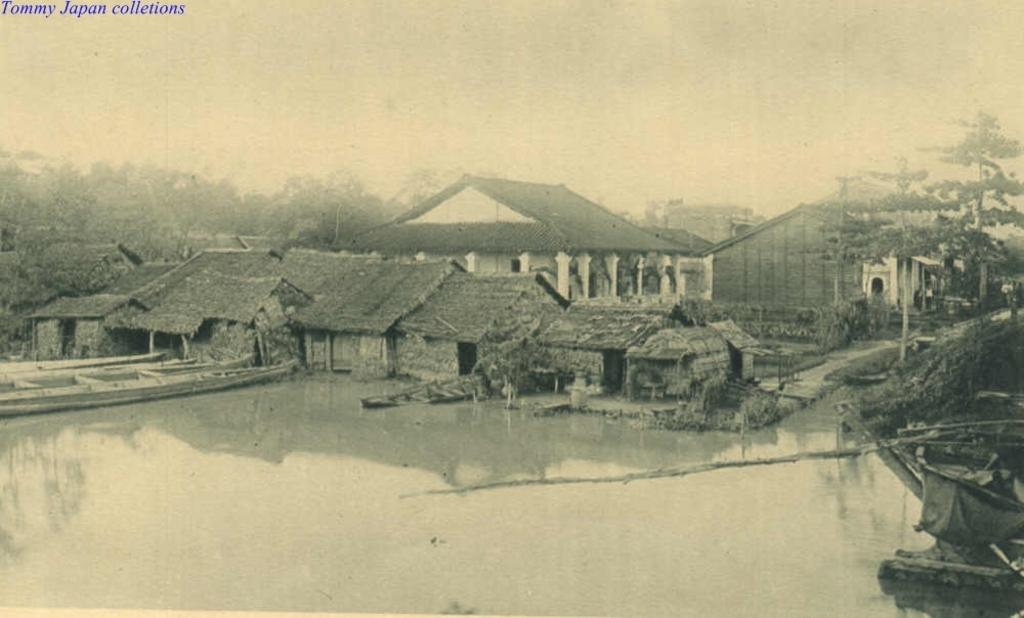What type of structures can be seen in the image? There are houses in the image. What other natural elements are present in the image? There are trees and water visible in the image. Is there any text included in the image? Yes, there is text at the top of the image. What is the color scheme of the image? The image is in black and white. How many cows are grazing in the water in the image? There are no cows present in the image; it features houses, trees, water, and text. What type of wool is being used to create the text in the image? There is no wool present in the image, as the text is in black and white and not a physical material. 